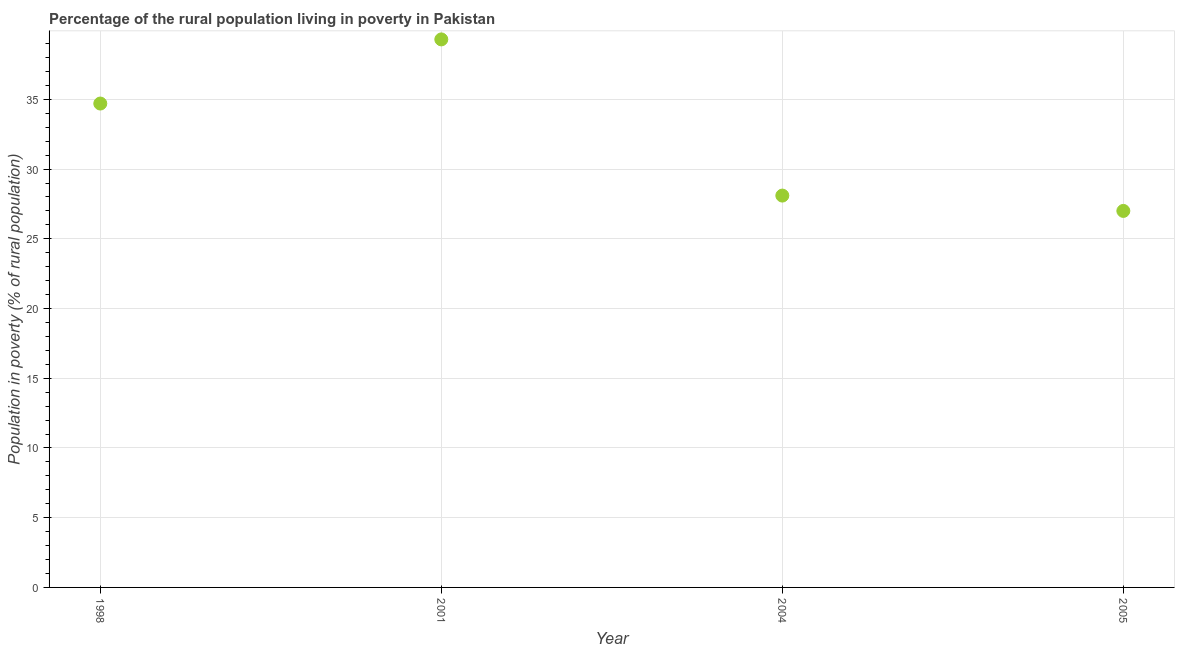What is the percentage of rural population living below poverty line in 1998?
Offer a very short reply. 34.7. Across all years, what is the maximum percentage of rural population living below poverty line?
Provide a short and direct response. 39.3. Across all years, what is the minimum percentage of rural population living below poverty line?
Offer a very short reply. 27. In which year was the percentage of rural population living below poverty line maximum?
Keep it short and to the point. 2001. What is the sum of the percentage of rural population living below poverty line?
Your answer should be compact. 129.1. What is the difference between the percentage of rural population living below poverty line in 1998 and 2001?
Provide a succinct answer. -4.6. What is the average percentage of rural population living below poverty line per year?
Your answer should be compact. 32.27. What is the median percentage of rural population living below poverty line?
Make the answer very short. 31.4. In how many years, is the percentage of rural population living below poverty line greater than 35 %?
Your answer should be compact. 1. What is the ratio of the percentage of rural population living below poverty line in 1998 to that in 2004?
Keep it short and to the point. 1.23. Is the percentage of rural population living below poverty line in 2001 less than that in 2005?
Your answer should be compact. No. What is the difference between the highest and the second highest percentage of rural population living below poverty line?
Your response must be concise. 4.6. Is the sum of the percentage of rural population living below poverty line in 1998 and 2005 greater than the maximum percentage of rural population living below poverty line across all years?
Your answer should be very brief. Yes. What is the difference between the highest and the lowest percentage of rural population living below poverty line?
Your response must be concise. 12.3. How many dotlines are there?
Ensure brevity in your answer.  1. How many years are there in the graph?
Your answer should be very brief. 4. Are the values on the major ticks of Y-axis written in scientific E-notation?
Your response must be concise. No. Does the graph contain grids?
Ensure brevity in your answer.  Yes. What is the title of the graph?
Your answer should be compact. Percentage of the rural population living in poverty in Pakistan. What is the label or title of the Y-axis?
Give a very brief answer. Population in poverty (% of rural population). What is the Population in poverty (% of rural population) in 1998?
Keep it short and to the point. 34.7. What is the Population in poverty (% of rural population) in 2001?
Offer a terse response. 39.3. What is the Population in poverty (% of rural population) in 2004?
Your answer should be compact. 28.1. What is the Population in poverty (% of rural population) in 2005?
Your response must be concise. 27. What is the difference between the Population in poverty (% of rural population) in 1998 and 2001?
Offer a very short reply. -4.6. What is the difference between the Population in poverty (% of rural population) in 2001 and 2004?
Provide a short and direct response. 11.2. What is the difference between the Population in poverty (% of rural population) in 2004 and 2005?
Provide a short and direct response. 1.1. What is the ratio of the Population in poverty (% of rural population) in 1998 to that in 2001?
Ensure brevity in your answer.  0.88. What is the ratio of the Population in poverty (% of rural population) in 1998 to that in 2004?
Keep it short and to the point. 1.24. What is the ratio of the Population in poverty (% of rural population) in 1998 to that in 2005?
Offer a terse response. 1.28. What is the ratio of the Population in poverty (% of rural population) in 2001 to that in 2004?
Your response must be concise. 1.4. What is the ratio of the Population in poverty (% of rural population) in 2001 to that in 2005?
Keep it short and to the point. 1.46. What is the ratio of the Population in poverty (% of rural population) in 2004 to that in 2005?
Provide a succinct answer. 1.04. 